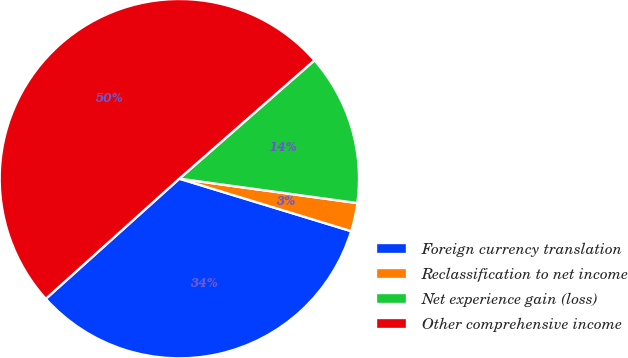<chart> <loc_0><loc_0><loc_500><loc_500><pie_chart><fcel>Foreign currency translation<fcel>Reclassification to net income<fcel>Net experience gain (loss)<fcel>Other comprehensive income<nl><fcel>33.62%<fcel>2.55%<fcel>13.62%<fcel>50.21%<nl></chart> 